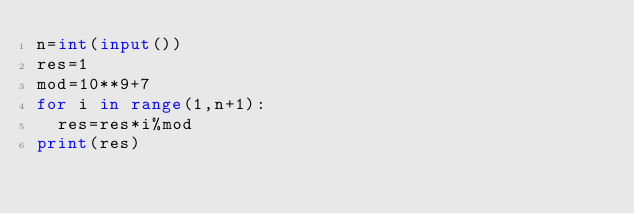<code> <loc_0><loc_0><loc_500><loc_500><_Python_>n=int(input())
res=1
mod=10**9+7
for i in range(1,n+1):
  res=res*i%mod
print(res)</code> 